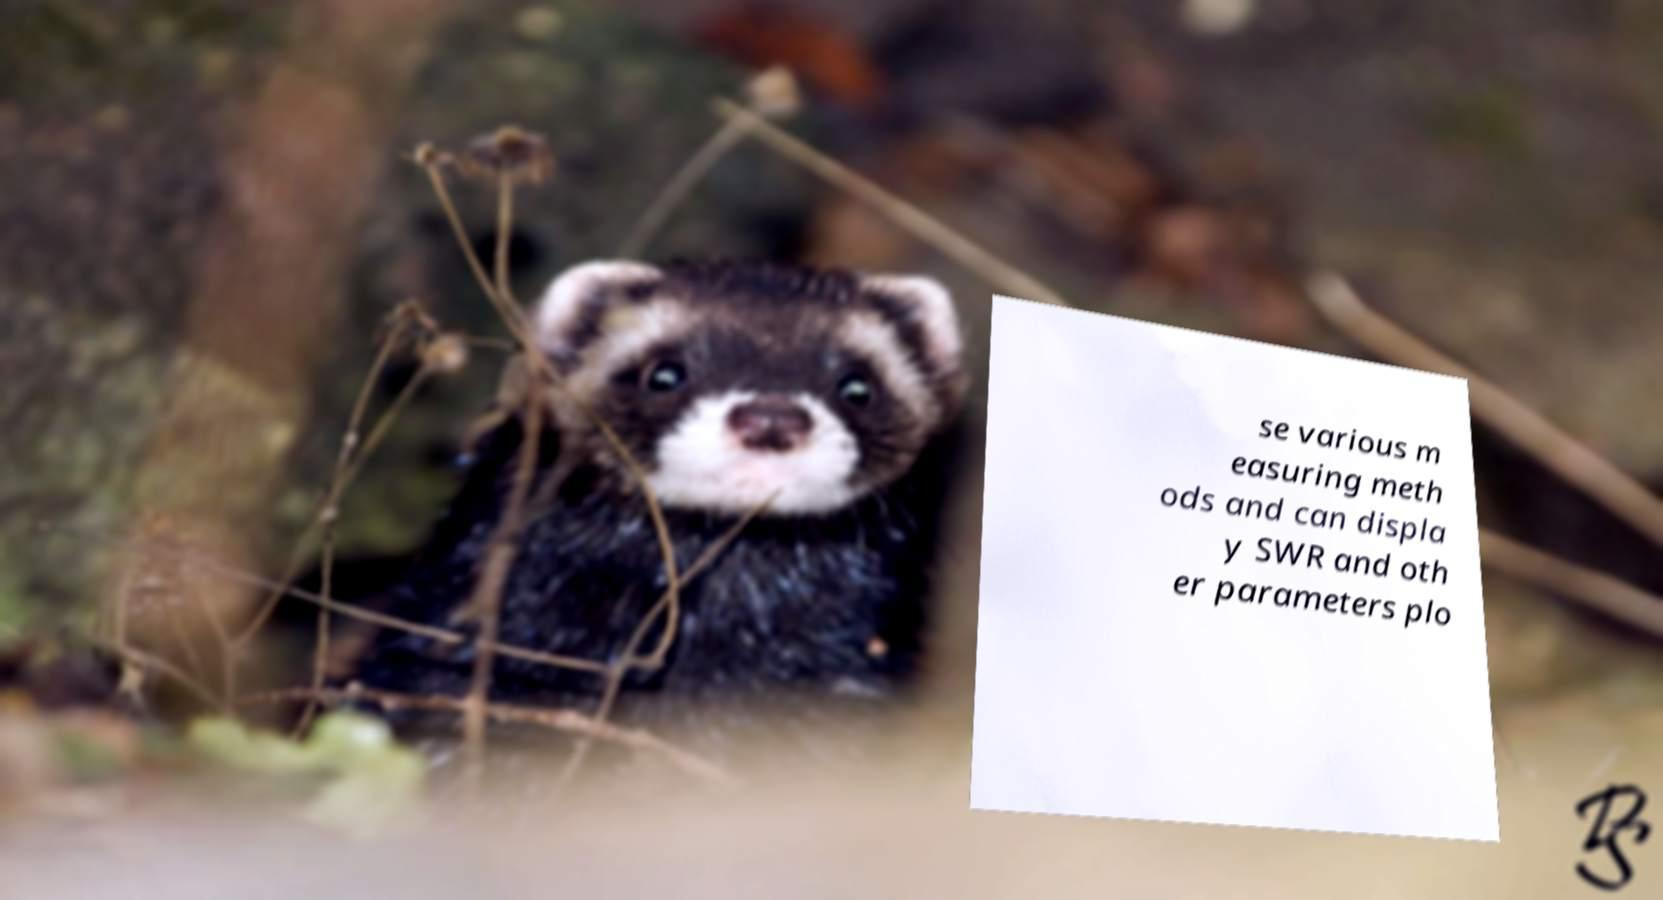Can you accurately transcribe the text from the provided image for me? se various m easuring meth ods and can displa y SWR and oth er parameters plo 